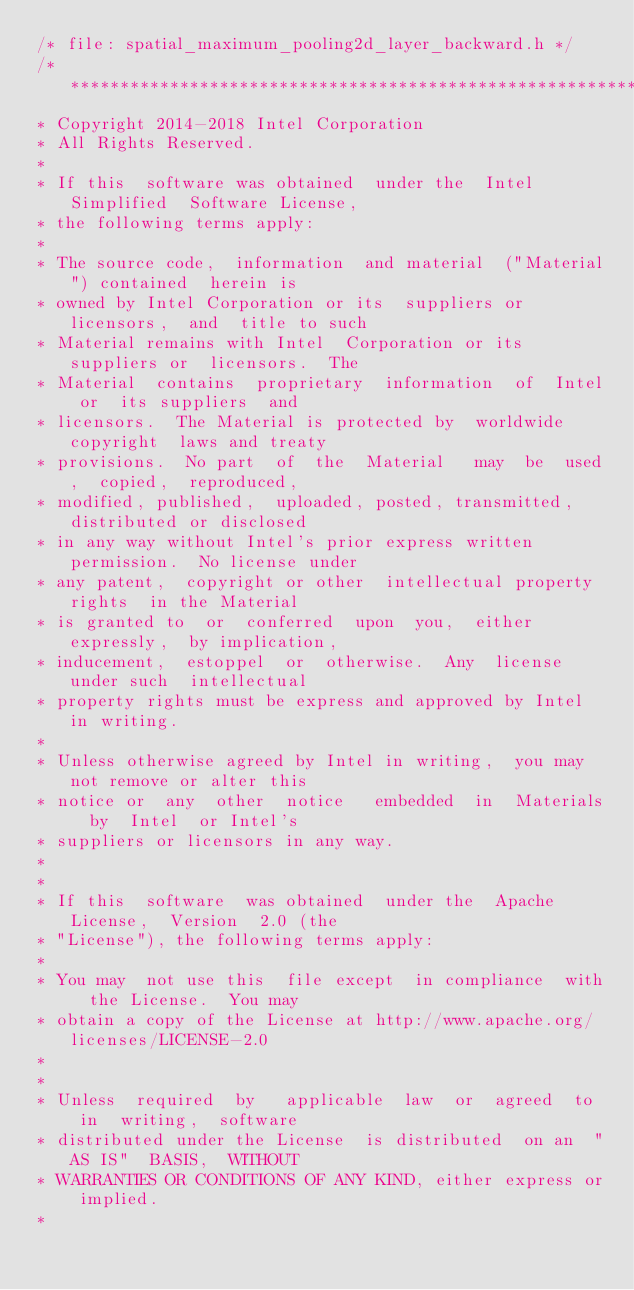Convert code to text. <code><loc_0><loc_0><loc_500><loc_500><_C_>/* file: spatial_maximum_pooling2d_layer_backward.h */
/*******************************************************************************
* Copyright 2014-2018 Intel Corporation
* All Rights Reserved.
*
* If this  software was obtained  under the  Intel Simplified  Software License,
* the following terms apply:
*
* The source code,  information  and material  ("Material") contained  herein is
* owned by Intel Corporation or its  suppliers or licensors,  and  title to such
* Material remains with Intel  Corporation or its  suppliers or  licensors.  The
* Material  contains  proprietary  information  of  Intel or  its suppliers  and
* licensors.  The Material is protected by  worldwide copyright  laws and treaty
* provisions.  No part  of  the  Material   may  be  used,  copied,  reproduced,
* modified, published,  uploaded, posted, transmitted,  distributed or disclosed
* in any way without Intel's prior express written permission.  No license under
* any patent,  copyright or other  intellectual property rights  in the Material
* is granted to  or  conferred  upon  you,  either   expressly,  by implication,
* inducement,  estoppel  or  otherwise.  Any  license   under such  intellectual
* property rights must be express and approved by Intel in writing.
*
* Unless otherwise agreed by Intel in writing,  you may not remove or alter this
* notice or  any  other  notice   embedded  in  Materials  by  Intel  or Intel's
* suppliers or licensors in any way.
*
*
* If this  software  was obtained  under the  Apache License,  Version  2.0 (the
* "License"), the following terms apply:
*
* You may  not use this  file except  in compliance  with  the License.  You may
* obtain a copy of the License at http://www.apache.org/licenses/LICENSE-2.0
*
*
* Unless  required  by   applicable  law  or  agreed  to  in  writing,  software
* distributed under the License  is distributed  on an  "AS IS"  BASIS,  WITHOUT
* WARRANTIES OR CONDITIONS OF ANY KIND, either express or implied.
*</code> 